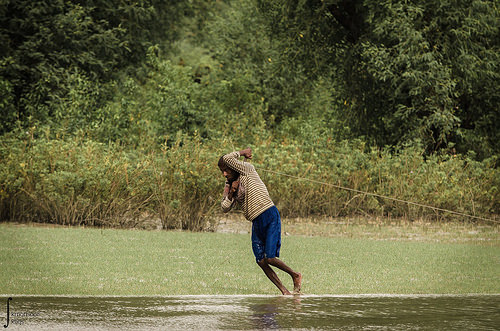<image>
Is there a person on the rope? Yes. Looking at the image, I can see the person is positioned on top of the rope, with the rope providing support. Is the water behind the man? No. The water is not behind the man. From this viewpoint, the water appears to be positioned elsewhere in the scene. 